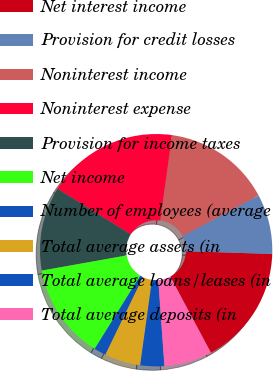Convert chart. <chart><loc_0><loc_0><loc_500><loc_500><pie_chart><fcel>Net interest income<fcel>Provision for credit losses<fcel>Noninterest income<fcel>Noninterest expense<fcel>Provision for income taxes<fcel>Net income<fcel>Number of employees (average<fcel>Total average assets (in<fcel>Total average loans/leases (in<fcel>Total average deposits (in<nl><fcel>16.67%<fcel>8.33%<fcel>15.0%<fcel>18.33%<fcel>11.67%<fcel>13.33%<fcel>1.67%<fcel>5.0%<fcel>3.33%<fcel>6.67%<nl></chart> 